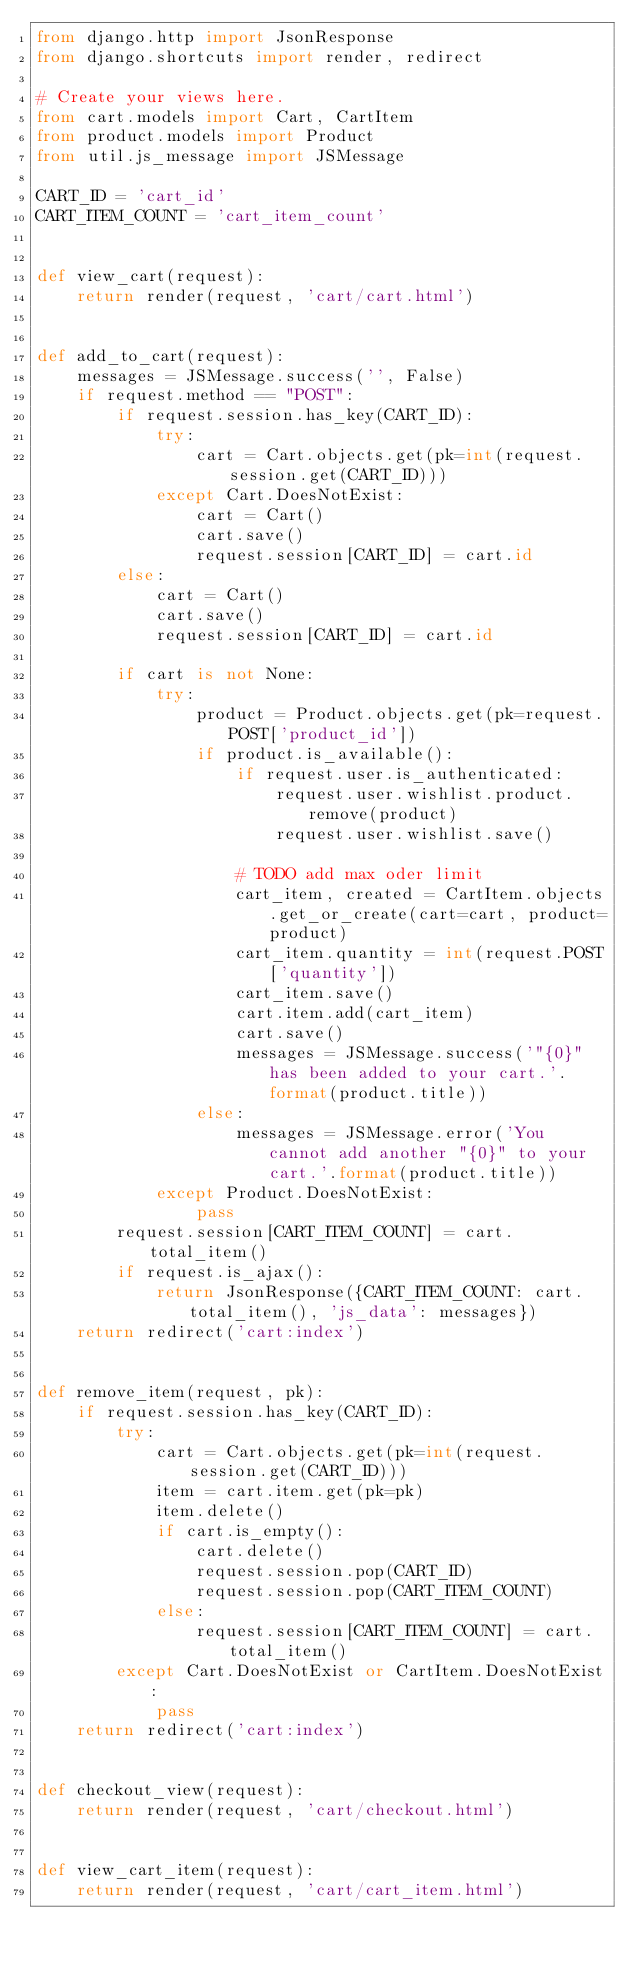<code> <loc_0><loc_0><loc_500><loc_500><_Python_>from django.http import JsonResponse
from django.shortcuts import render, redirect

# Create your views here.
from cart.models import Cart, CartItem
from product.models import Product
from util.js_message import JSMessage

CART_ID = 'cart_id'
CART_ITEM_COUNT = 'cart_item_count'


def view_cart(request):
    return render(request, 'cart/cart.html')


def add_to_cart(request):
    messages = JSMessage.success('', False)
    if request.method == "POST":
        if request.session.has_key(CART_ID):
            try:
                cart = Cart.objects.get(pk=int(request.session.get(CART_ID)))
            except Cart.DoesNotExist:
                cart = Cart()
                cart.save()
                request.session[CART_ID] = cart.id
        else:
            cart = Cart()
            cart.save()
            request.session[CART_ID] = cart.id

        if cart is not None:
            try:
                product = Product.objects.get(pk=request.POST['product_id'])
                if product.is_available():
                    if request.user.is_authenticated:
                        request.user.wishlist.product.remove(product)
                        request.user.wishlist.save()

                    # TODO add max oder limit
                    cart_item, created = CartItem.objects.get_or_create(cart=cart, product=product)
                    cart_item.quantity = int(request.POST['quantity'])
                    cart_item.save()
                    cart.item.add(cart_item)
                    cart.save()
                    messages = JSMessage.success('"{0}" has been added to your cart.'.format(product.title))
                else:
                    messages = JSMessage.error('You cannot add another "{0}" to your cart.'.format(product.title))
            except Product.DoesNotExist:
                pass
        request.session[CART_ITEM_COUNT] = cart.total_item()
        if request.is_ajax():
            return JsonResponse({CART_ITEM_COUNT: cart.total_item(), 'js_data': messages})
    return redirect('cart:index')


def remove_item(request, pk):
    if request.session.has_key(CART_ID):
        try:
            cart = Cart.objects.get(pk=int(request.session.get(CART_ID)))
            item = cart.item.get(pk=pk)
            item.delete()
            if cart.is_empty():
                cart.delete()
                request.session.pop(CART_ID)
                request.session.pop(CART_ITEM_COUNT)
            else:
                request.session[CART_ITEM_COUNT] = cart.total_item()
        except Cart.DoesNotExist or CartItem.DoesNotExist:
            pass
    return redirect('cart:index')


def checkout_view(request):
    return render(request, 'cart/checkout.html')


def view_cart_item(request):
    return render(request, 'cart/cart_item.html')
</code> 